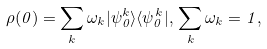<formula> <loc_0><loc_0><loc_500><loc_500>\rho ( 0 ) = \sum _ { k } \omega _ { k } | \psi _ { 0 } ^ { k } \rangle \langle \psi _ { 0 } ^ { k } | , \, \sum _ { k } \omega _ { k } = 1 ,</formula> 